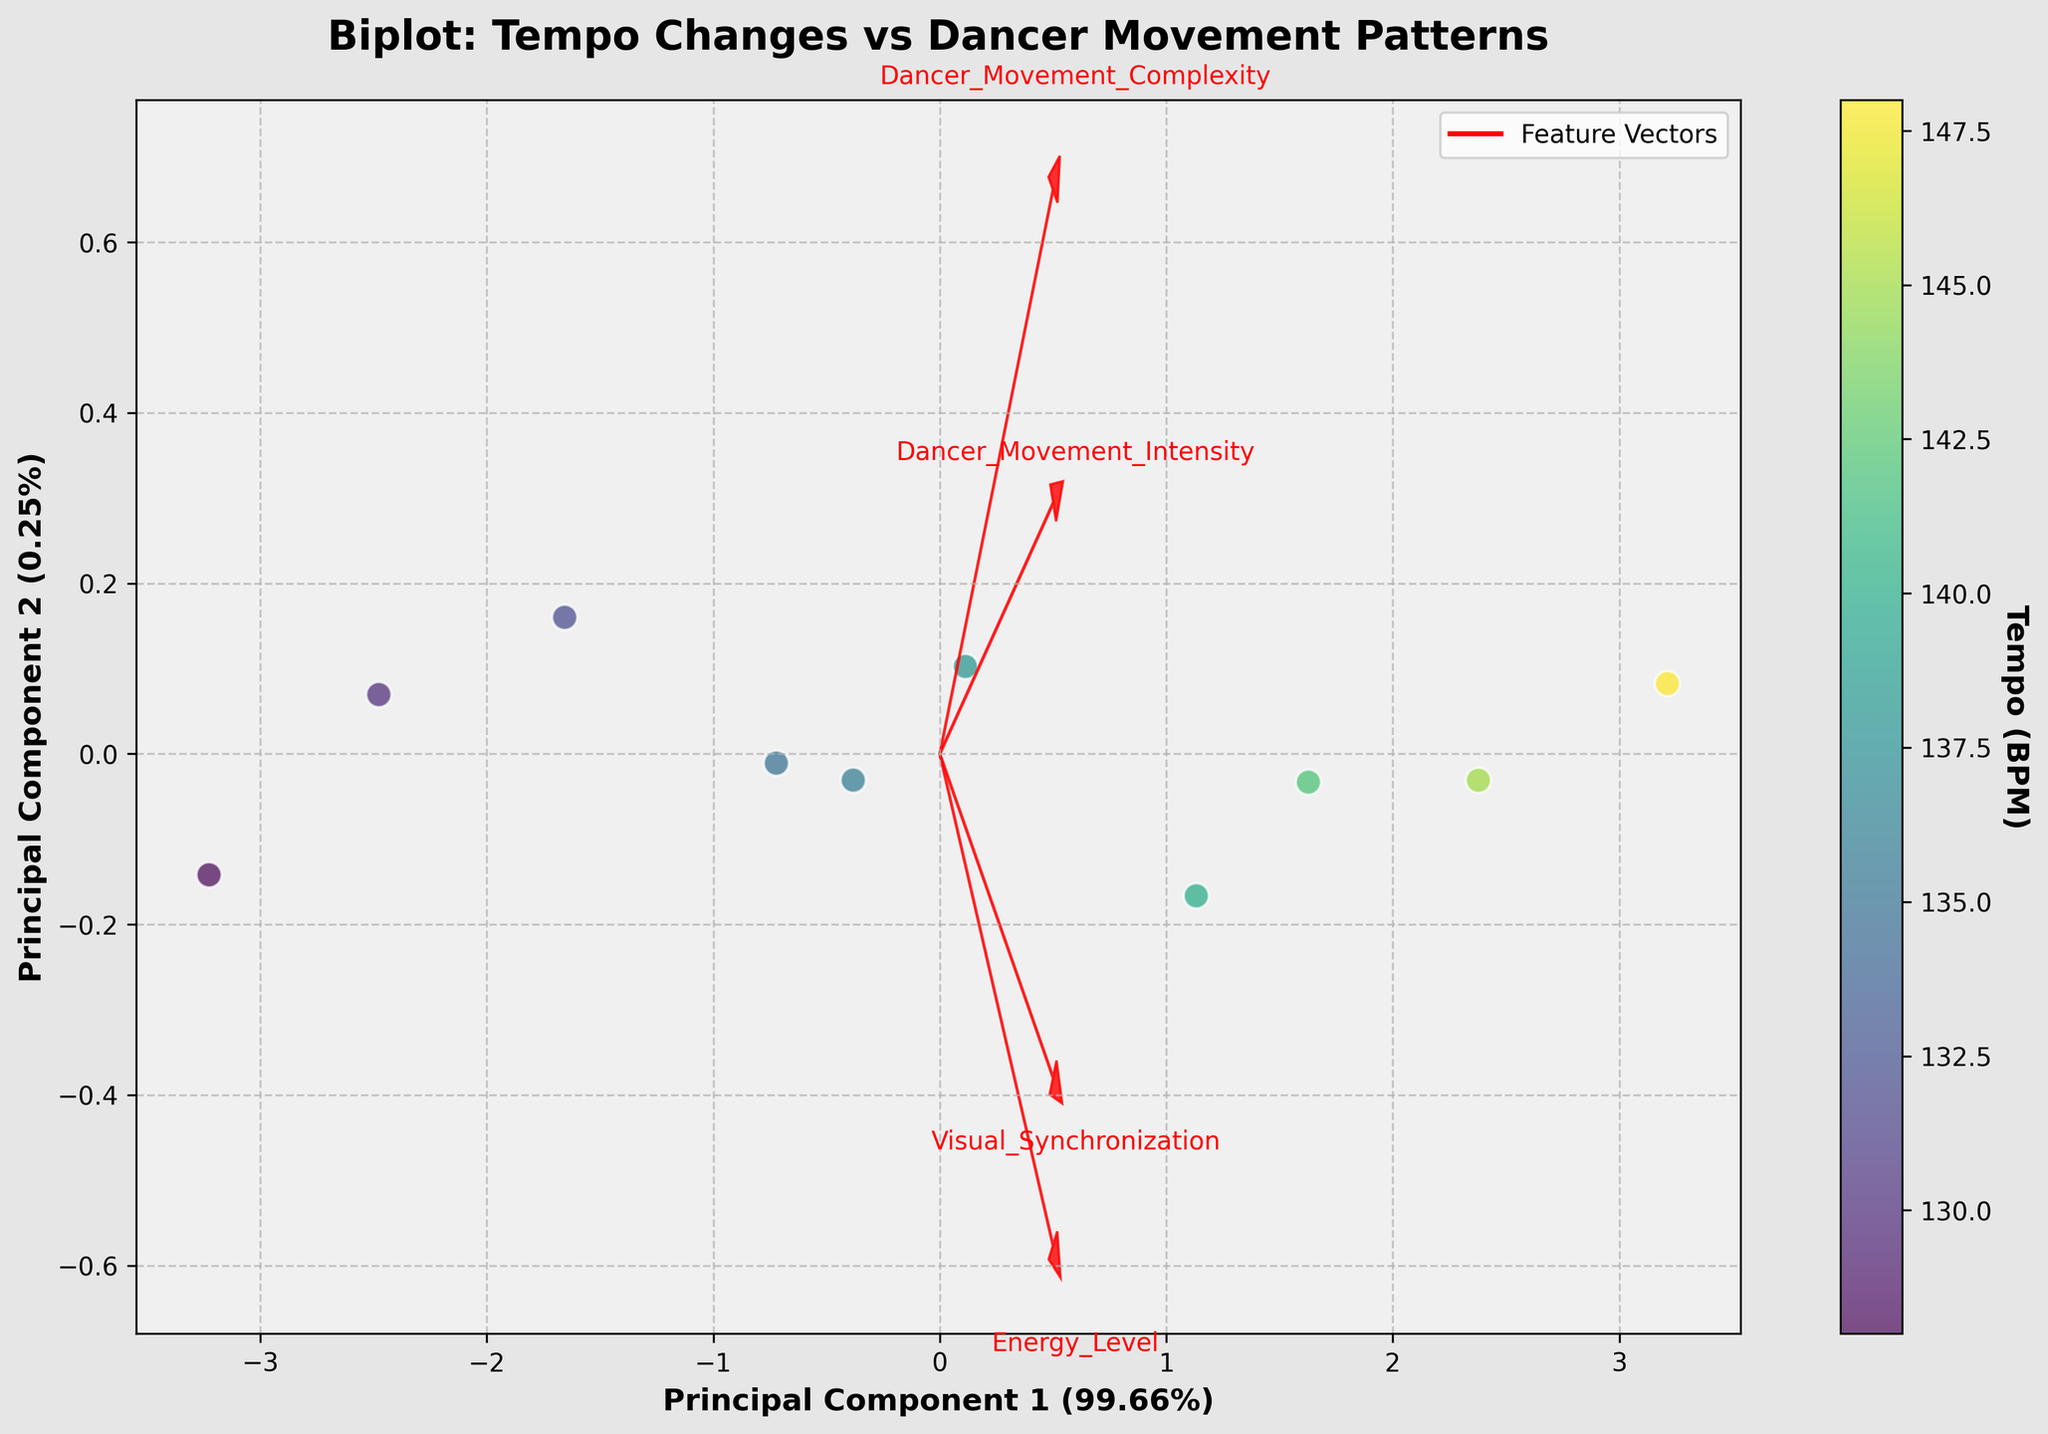What is the title of the biplot? The title is located at the top center of the figure. It reads: "Biplot: Tempo Changes vs Dancer Movement Patterns"
Answer: Biplot: Tempo Changes vs Dancer Movement Patterns How is the color of each data point determined? The color of each data point is determined by its Tempo (BPM). This can be seen from the color bar on the right side labeled "Tempo (BPM)" with a gradient of colors corresponding to different BPM values.
Answer: By Tempo (BPM) Which principal component explains the most variance? The principal component that explains the most variance is indicated by the x-axis label, which reads "Principal Component 1," along with its explained variance ratio (Percent).
Answer: Principal Component 1 What does the color bar on the right represent? The color bar represents the Tempo (BPM) of each data point, as indicated by its label.
Answer: Tempo (BPM) What feature has the highest positive loading on Principal Component 2? The feature vectors (red arrows) indicate the contribution of each feature to the principal components. The feature with the highest positive loading on Principal Component 2 can be found by looking at the arrow most aligned with the positive direction of the y-axis.
Answer: Visual_Synchronization Which feature vector is most aligned with Principal Component 1? Identify the red arrow that is most aligned with the x-axis (Principal Component 1). The text next to the arrow will indicate the feature.
Answer: Energy_Level How many data points are depicted in the biplot? Count the number of scatter plot points in the figure. Each point represents one data entry from the dataset.
Answer: 10 Compare Dancer_Movement_Intensity and Dancer_Movement_Complexity: which has a bigger contribution to Principal Component 1? Look at the red arrows for both Dancer_Movement_Intensity and Dancer_Movement_Complexity. The one that points further along the x-axis (Principal Component 1) indicates a bigger contribution
Answer: Dancer_Movement_Intensity Which feature appears to be least correlated with the principal components? Identify the feature vector (red arrow) that is shortest and closest to the origin in any direction, indicating it has the least contribution to the principal components.
Answer: Dancer_Movement_Complexity 